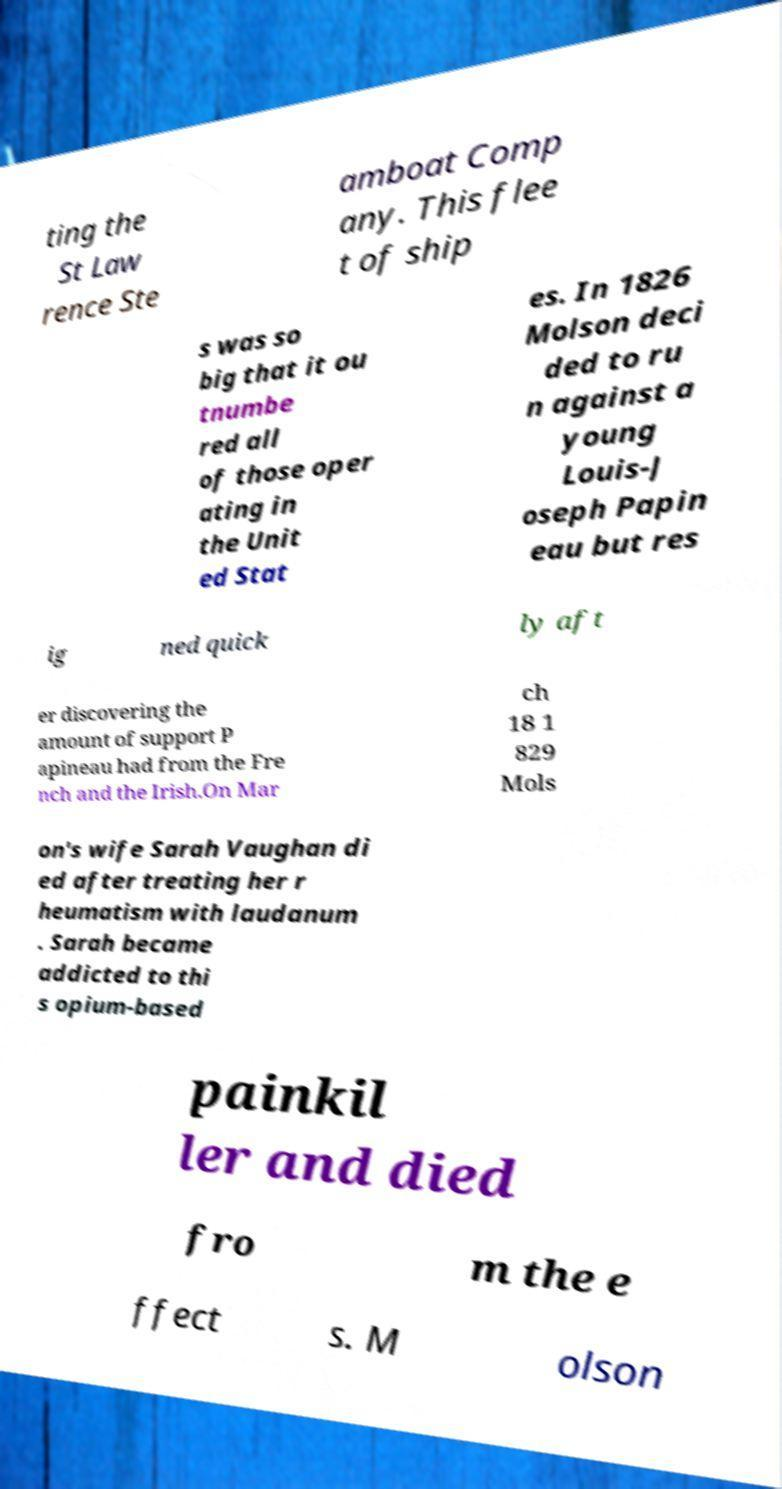Can you accurately transcribe the text from the provided image for me? ting the St Law rence Ste amboat Comp any. This flee t of ship s was so big that it ou tnumbe red all of those oper ating in the Unit ed Stat es. In 1826 Molson deci ded to ru n against a young Louis-J oseph Papin eau but res ig ned quick ly aft er discovering the amount of support P apineau had from the Fre nch and the Irish.On Mar ch 18 1 829 Mols on's wife Sarah Vaughan di ed after treating her r heumatism with laudanum . Sarah became addicted to thi s opium-based painkil ler and died fro m the e ffect s. M olson 